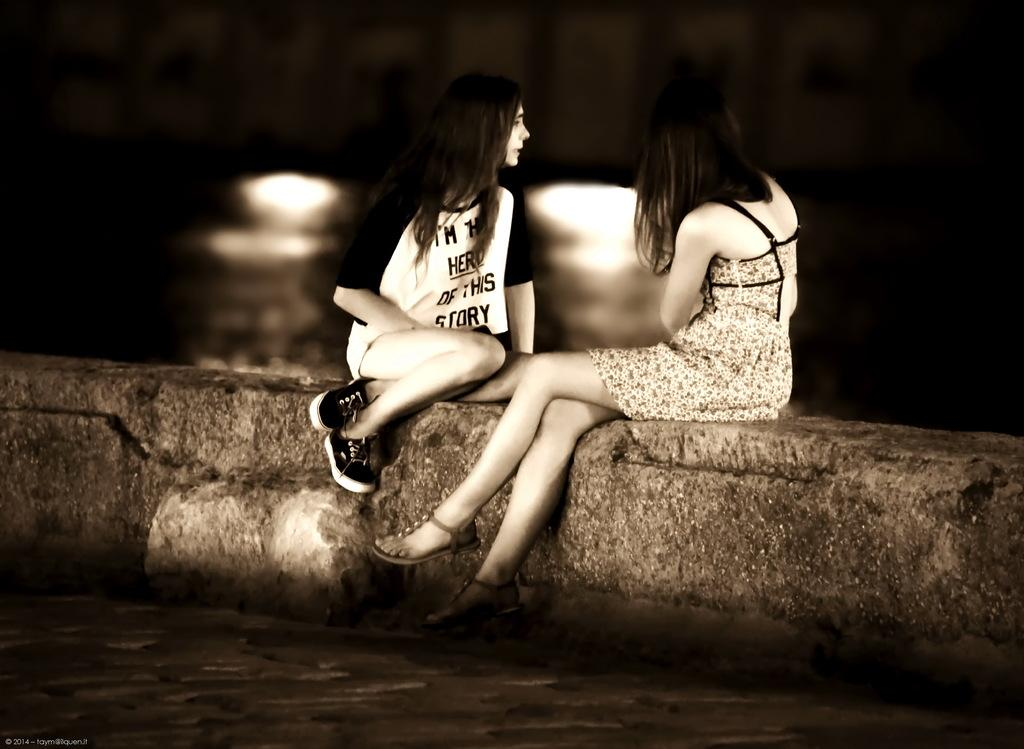How many people are in the image? There are two women in the image. What are the women doing in the image? The women are sitting on a wall. What type of lead is being used by the women in the image? There is no lead present in the image; the women are simply sitting on a wall. 